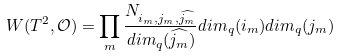Convert formula to latex. <formula><loc_0><loc_0><loc_500><loc_500>W ( T ^ { 2 } , \mathcal { O } ) = \prod _ { m } \frac { N _ { i _ { m } , j _ { m } , \widehat { j _ { m } } } } { d i m _ { q } ( \widehat { j _ { m } } ) } d i m _ { q } ( i _ { m } ) d i m _ { q } ( j _ { m } )</formula> 